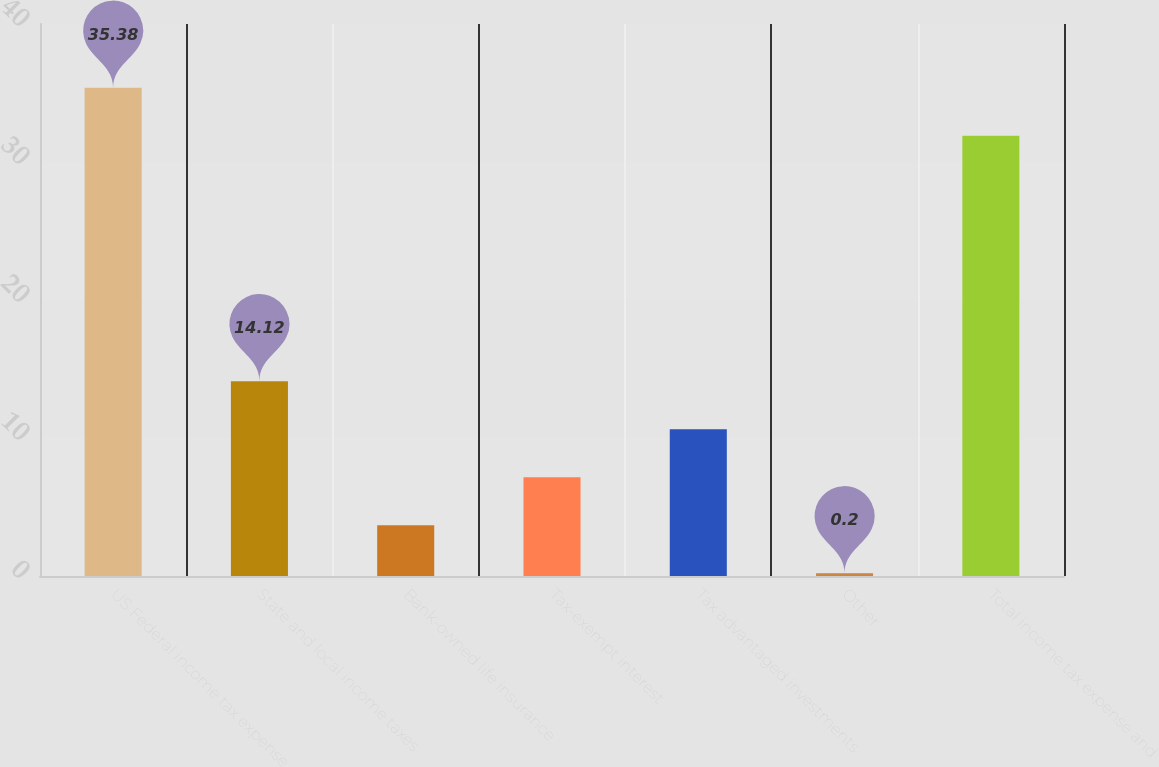Convert chart. <chart><loc_0><loc_0><loc_500><loc_500><bar_chart><fcel>US Federal income tax expense<fcel>State and local income taxes<fcel>Bank-owned life insurance<fcel>Tax-exempt interest<fcel>Tax advantaged investments<fcel>Other<fcel>Total income tax expense and<nl><fcel>35.38<fcel>14.12<fcel>3.68<fcel>7.16<fcel>10.64<fcel>0.2<fcel>31.9<nl></chart> 